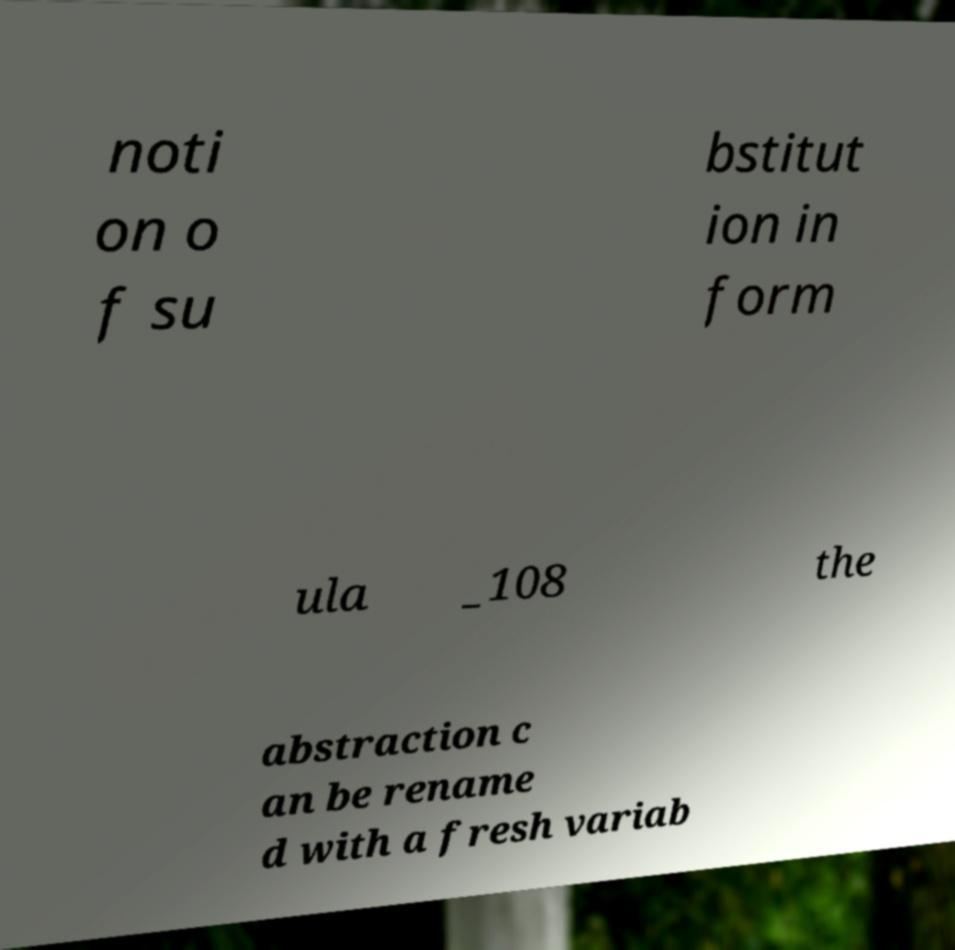Can you read and provide the text displayed in the image?This photo seems to have some interesting text. Can you extract and type it out for me? noti on o f su bstitut ion in form ula _108 the abstraction c an be rename d with a fresh variab 